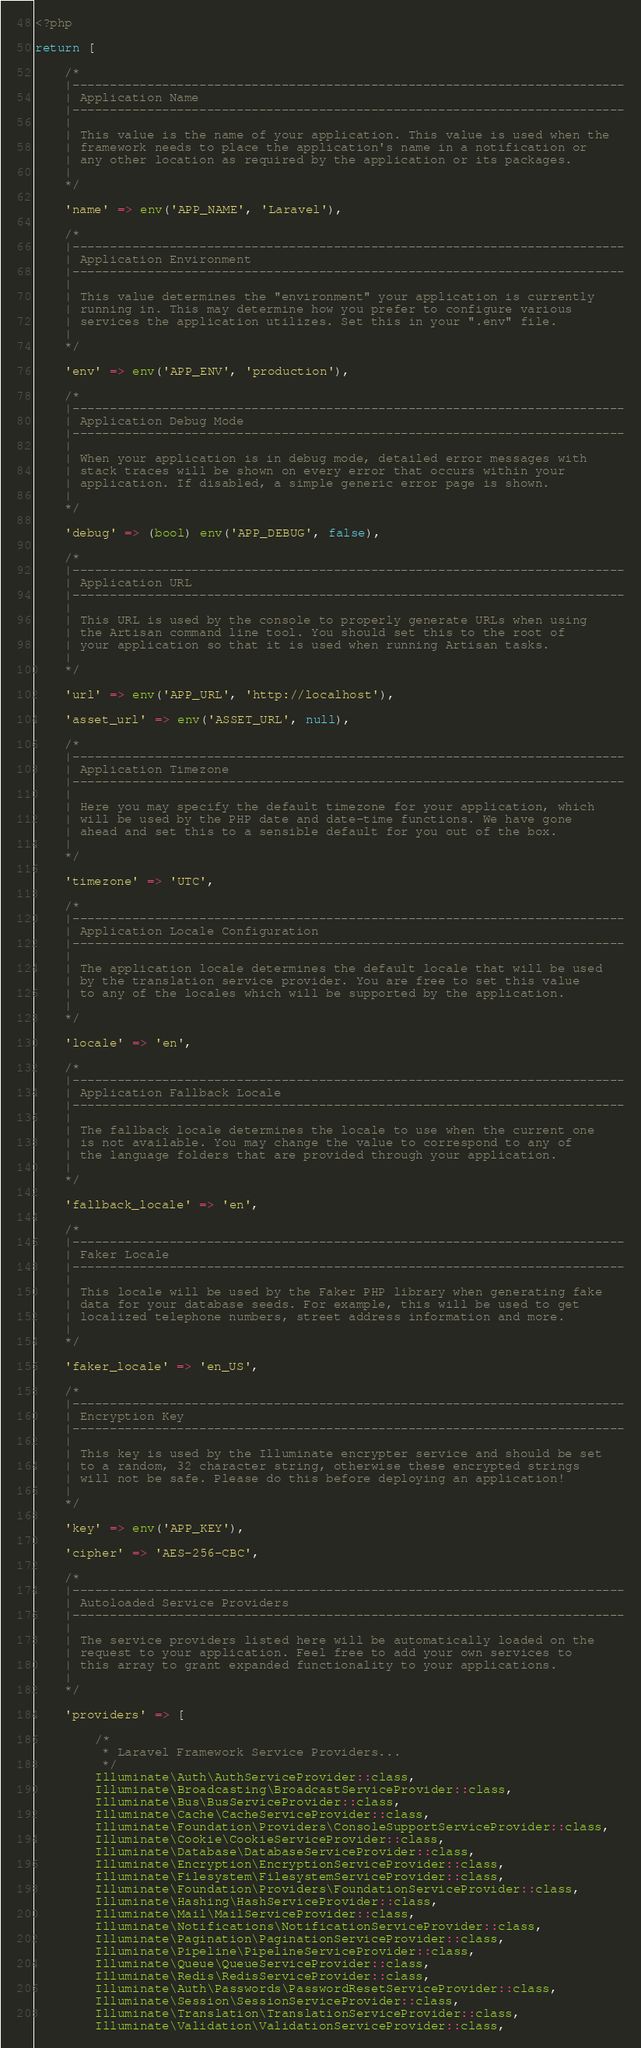Convert code to text. <code><loc_0><loc_0><loc_500><loc_500><_PHP_><?php

return [

    /*
    |--------------------------------------------------------------------------
    | Application Name
    |--------------------------------------------------------------------------
    |
    | This value is the name of your application. This value is used when the
    | framework needs to place the application's name in a notification or
    | any other location as required by the application or its packages.
    |
    */

    'name' => env('APP_NAME', 'Laravel'),

    /*
    |--------------------------------------------------------------------------
    | Application Environment
    |--------------------------------------------------------------------------
    |
    | This value determines the "environment" your application is currently
    | running in. This may determine how you prefer to configure various
    | services the application utilizes. Set this in your ".env" file.
    |
    */

    'env' => env('APP_ENV', 'production'),

    /*
    |--------------------------------------------------------------------------
    | Application Debug Mode
    |--------------------------------------------------------------------------
    |
    | When your application is in debug mode, detailed error messages with
    | stack traces will be shown on every error that occurs within your
    | application. If disabled, a simple generic error page is shown.
    |
    */

    'debug' => (bool) env('APP_DEBUG', false),

    /*
    |--------------------------------------------------------------------------
    | Application URL
    |--------------------------------------------------------------------------
    |
    | This URL is used by the console to properly generate URLs when using
    | the Artisan command line tool. You should set this to the root of
    | your application so that it is used when running Artisan tasks.
    |
    */

    'url' => env('APP_URL', 'http://localhost'),

    'asset_url' => env('ASSET_URL', null),

    /*
    |--------------------------------------------------------------------------
    | Application Timezone
    |--------------------------------------------------------------------------
    |
    | Here you may specify the default timezone for your application, which
    | will be used by the PHP date and date-time functions. We have gone
    | ahead and set this to a sensible default for you out of the box.
    |
    */

    'timezone' => 'UTC',

    /*
    |--------------------------------------------------------------------------
    | Application Locale Configuration
    |--------------------------------------------------------------------------
    |
    | The application locale determines the default locale that will be used
    | by the translation service provider. You are free to set this value
    | to any of the locales which will be supported by the application.
    |
    */

    'locale' => 'en',

    /*
    |--------------------------------------------------------------------------
    | Application Fallback Locale
    |--------------------------------------------------------------------------
    |
    | The fallback locale determines the locale to use when the current one
    | is not available. You may change the value to correspond to any of
    | the language folders that are provided through your application.
    |
    */

    'fallback_locale' => 'en',

    /*
    |--------------------------------------------------------------------------
    | Faker Locale
    |--------------------------------------------------------------------------
    |
    | This locale will be used by the Faker PHP library when generating fake
    | data for your database seeds. For example, this will be used to get
    | localized telephone numbers, street address information and more.
    |
    */

    'faker_locale' => 'en_US',

    /*
    |--------------------------------------------------------------------------
    | Encryption Key
    |--------------------------------------------------------------------------
    |
    | This key is used by the Illuminate encrypter service and should be set
    | to a random, 32 character string, otherwise these encrypted strings
    | will not be safe. Please do this before deploying an application!
    |
    */

    'key' => env('APP_KEY'),

    'cipher' => 'AES-256-CBC',

    /*
    |--------------------------------------------------------------------------
    | Autoloaded Service Providers
    |--------------------------------------------------------------------------
    |
    | The service providers listed here will be automatically loaded on the
    | request to your application. Feel free to add your own services to
    | this array to grant expanded functionality to your applications.
    |
    */

    'providers' => [

        /*
         * Laravel Framework Service Providers...
         */
        Illuminate\Auth\AuthServiceProvider::class,
        Illuminate\Broadcasting\BroadcastServiceProvider::class,
        Illuminate\Bus\BusServiceProvider::class,
        Illuminate\Cache\CacheServiceProvider::class,
        Illuminate\Foundation\Providers\ConsoleSupportServiceProvider::class,
        Illuminate\Cookie\CookieServiceProvider::class,
        Illuminate\Database\DatabaseServiceProvider::class,
        Illuminate\Encryption\EncryptionServiceProvider::class,
        Illuminate\Filesystem\FilesystemServiceProvider::class,
        Illuminate\Foundation\Providers\FoundationServiceProvider::class,
        Illuminate\Hashing\HashServiceProvider::class,
        Illuminate\Mail\MailServiceProvider::class,
        Illuminate\Notifications\NotificationServiceProvider::class,
        Illuminate\Pagination\PaginationServiceProvider::class,
        Illuminate\Pipeline\PipelineServiceProvider::class,
        Illuminate\Queue\QueueServiceProvider::class,
        Illuminate\Redis\RedisServiceProvider::class,
        Illuminate\Auth\Passwords\PasswordResetServiceProvider::class,
        Illuminate\Session\SessionServiceProvider::class,
        Illuminate\Translation\TranslationServiceProvider::class,
        Illuminate\Validation\ValidationServiceProvider::class,</code> 